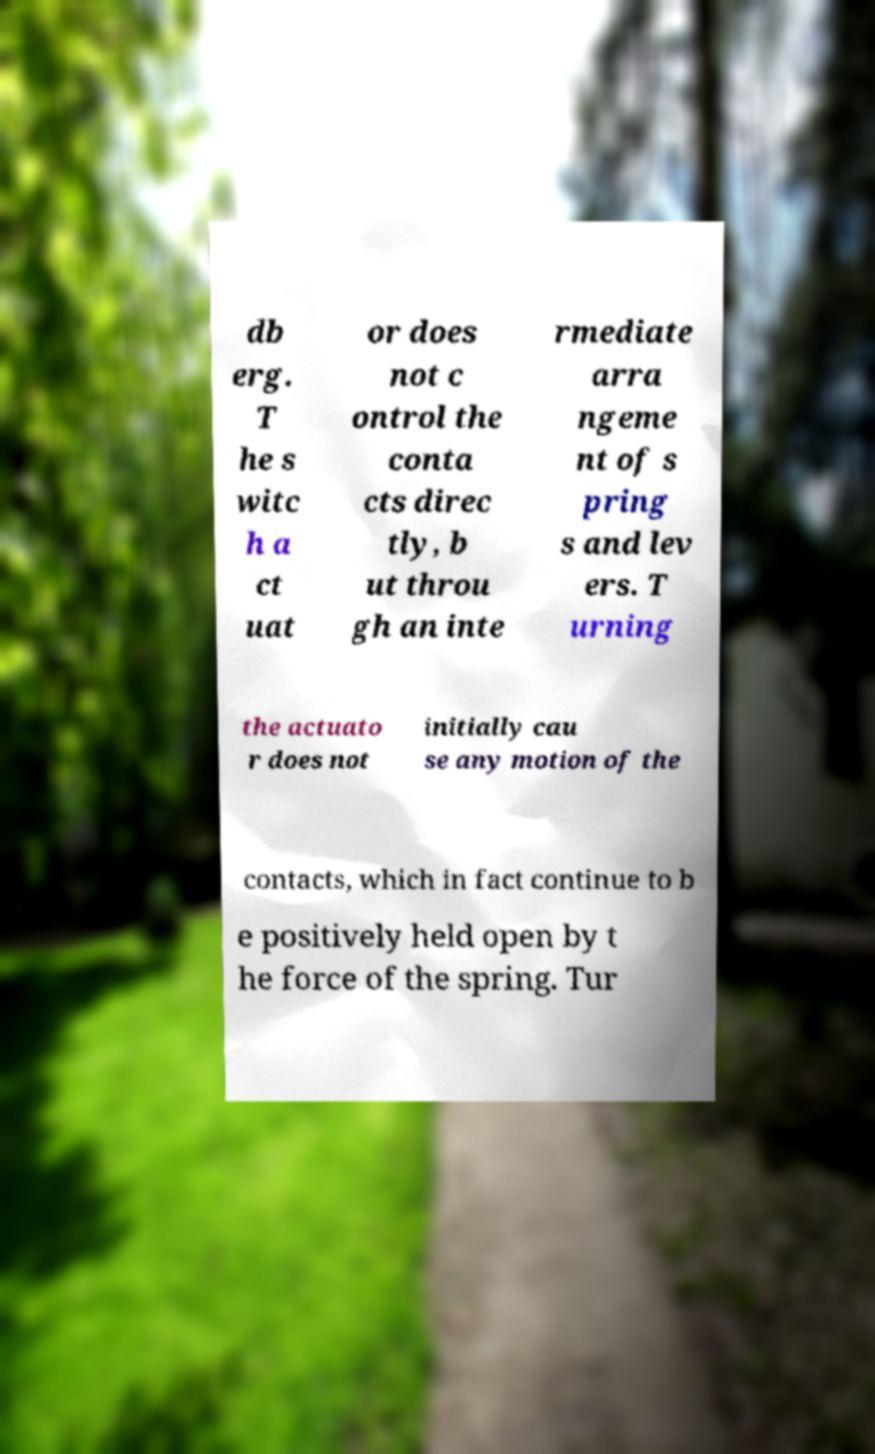Please identify and transcribe the text found in this image. db erg. T he s witc h a ct uat or does not c ontrol the conta cts direc tly, b ut throu gh an inte rmediate arra ngeme nt of s pring s and lev ers. T urning the actuato r does not initially cau se any motion of the contacts, which in fact continue to b e positively held open by t he force of the spring. Tur 